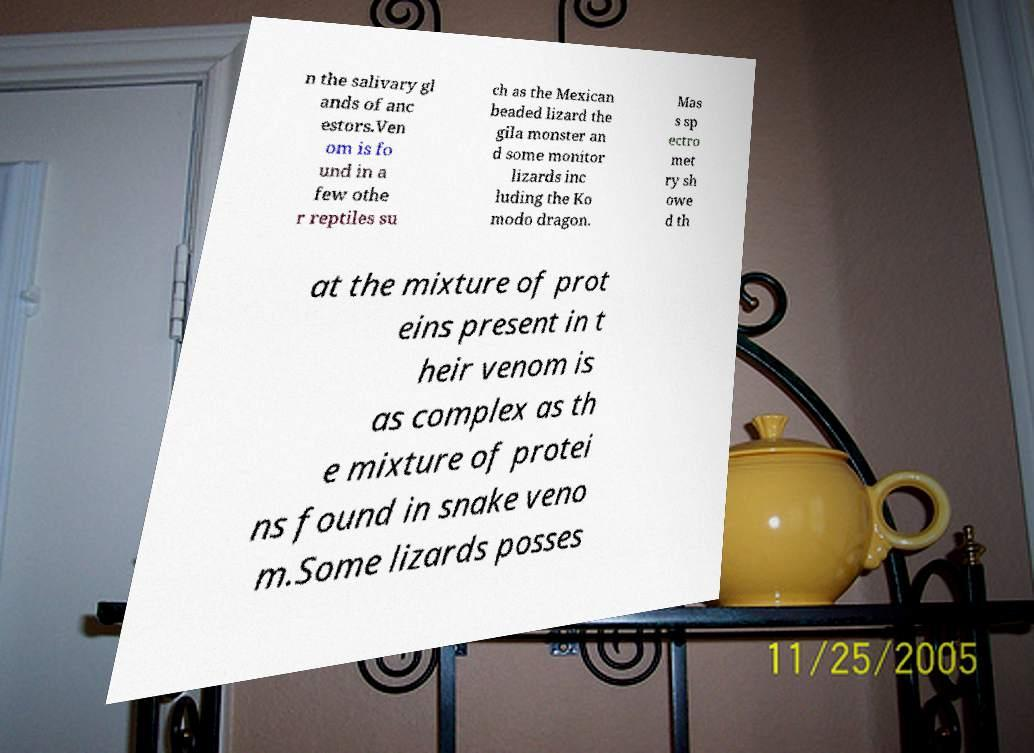There's text embedded in this image that I need extracted. Can you transcribe it verbatim? n the salivary gl ands of anc estors.Ven om is fo und in a few othe r reptiles su ch as the Mexican beaded lizard the gila monster an d some monitor lizards inc luding the Ko modo dragon. Mas s sp ectro met ry sh owe d th at the mixture of prot eins present in t heir venom is as complex as th e mixture of protei ns found in snake veno m.Some lizards posses 